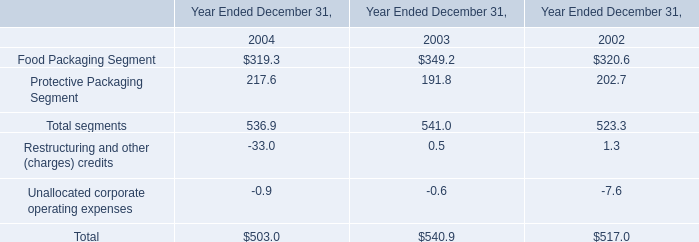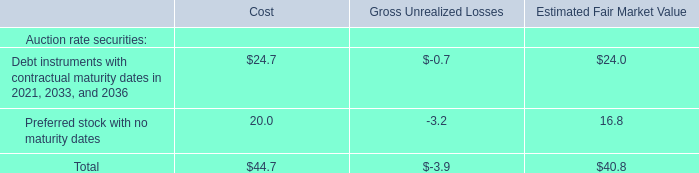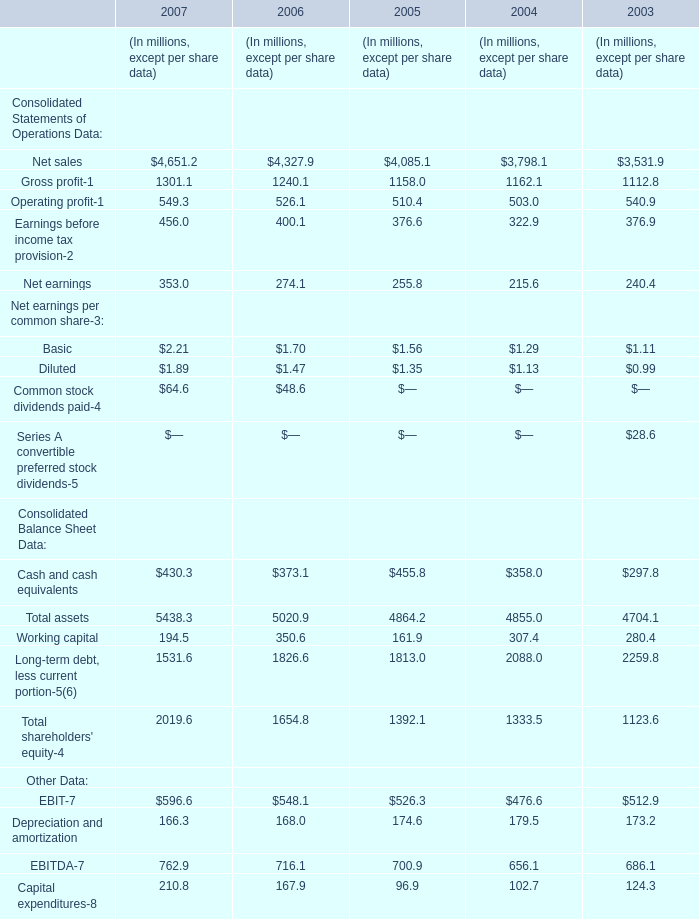What is the value of the Working capital for 2007 as As the chart 2 shows? (in million) 
Answer: 194.5. 